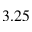<formula> <loc_0><loc_0><loc_500><loc_500>3 . 2 5</formula> 